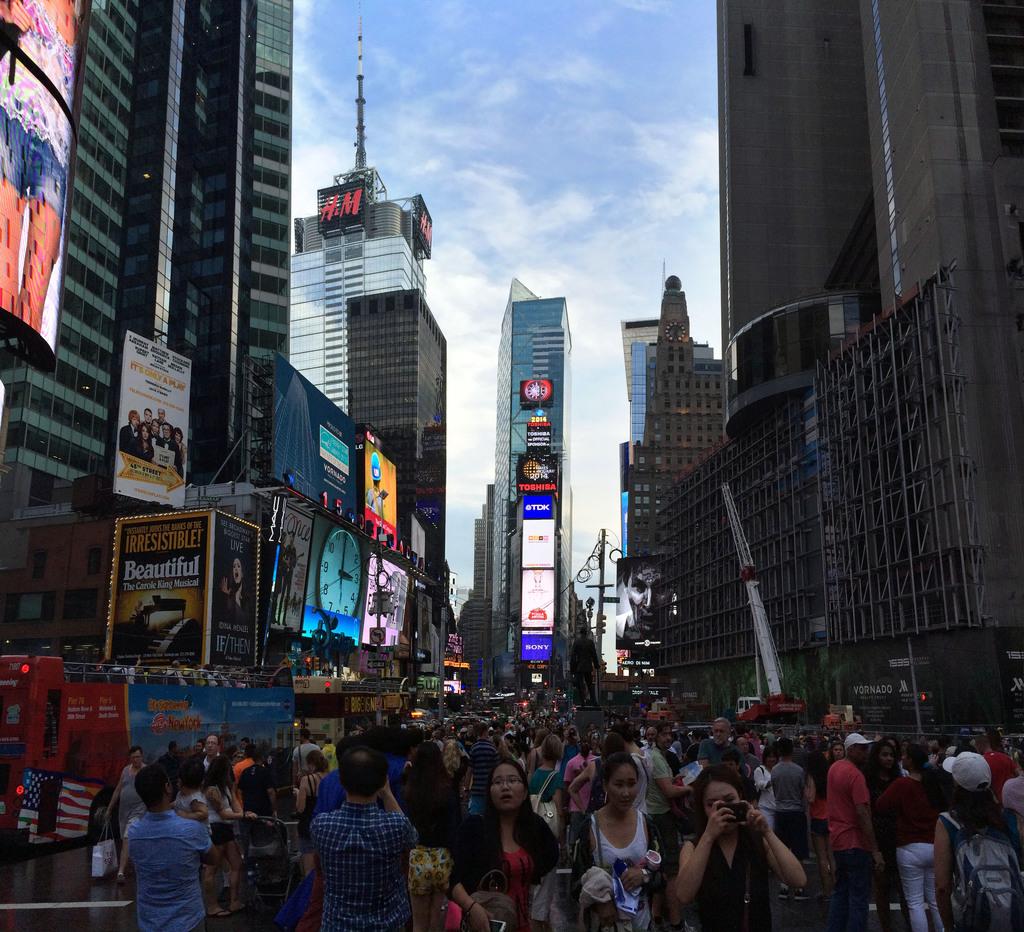What does the sign at the bottom left say?
Your answer should be very brief. Beautiful. Is there and hm building here?
Your response must be concise. Yes. 